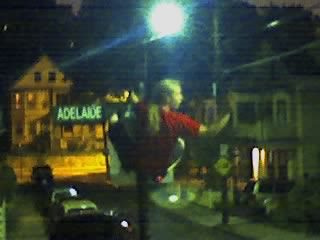Is the street busy, and can you point out any forms of transportation in the image? The street appears relatively calm with no signs of heavy traffic. There is a car visible on the left side of the street, parked or possibly in motion. What type of area does this appear to be — residential, commercial, or industrial? The presence of homes and what appears to be a residential structure on the left suggest that this is a residential area. The absence of storefronts or industrial facilities also supports this impression. 